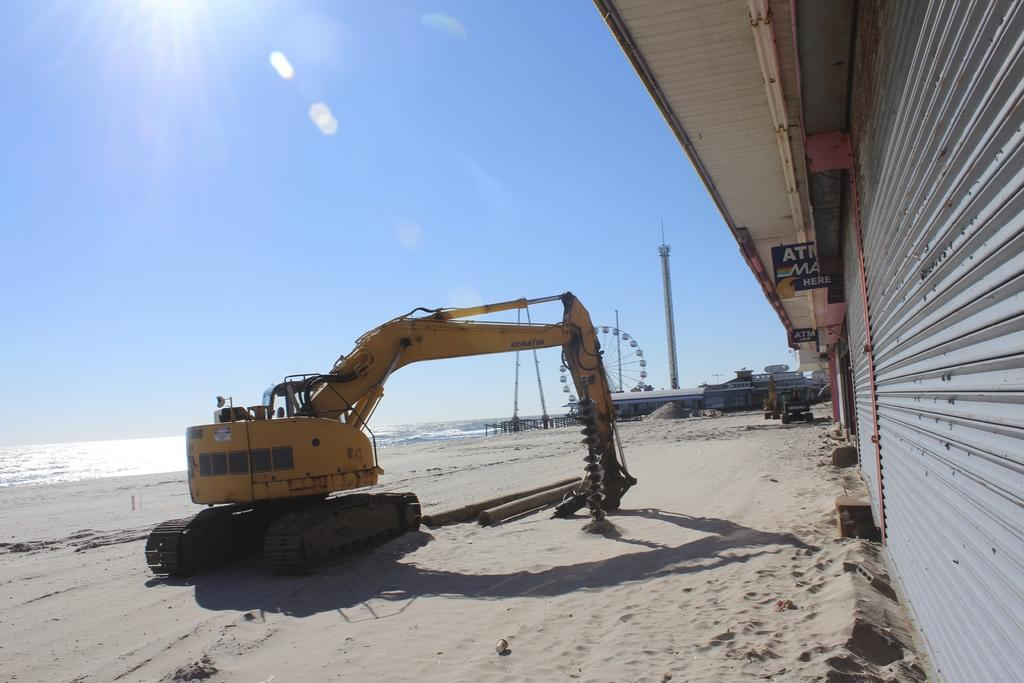What type of construction equipment can be seen in the image? There is an excavator in the image. What type of wheels are on the excavator? There are joint wheels in the image. What structures are present in the image? There are poles, a tower, sheds, and shutters in the image. What materials are visible in the image? There are boards and sand visible in the image. What natural elements can be seen in the image? There is water and the sky visible in the image. How does the fog affect the visibility of the excavator in the image? There is no fog present in the image, so it does not affect the visibility of the excavator. What type of drug is being used by the workers in the image? There are no workers or drugs present in the image. 